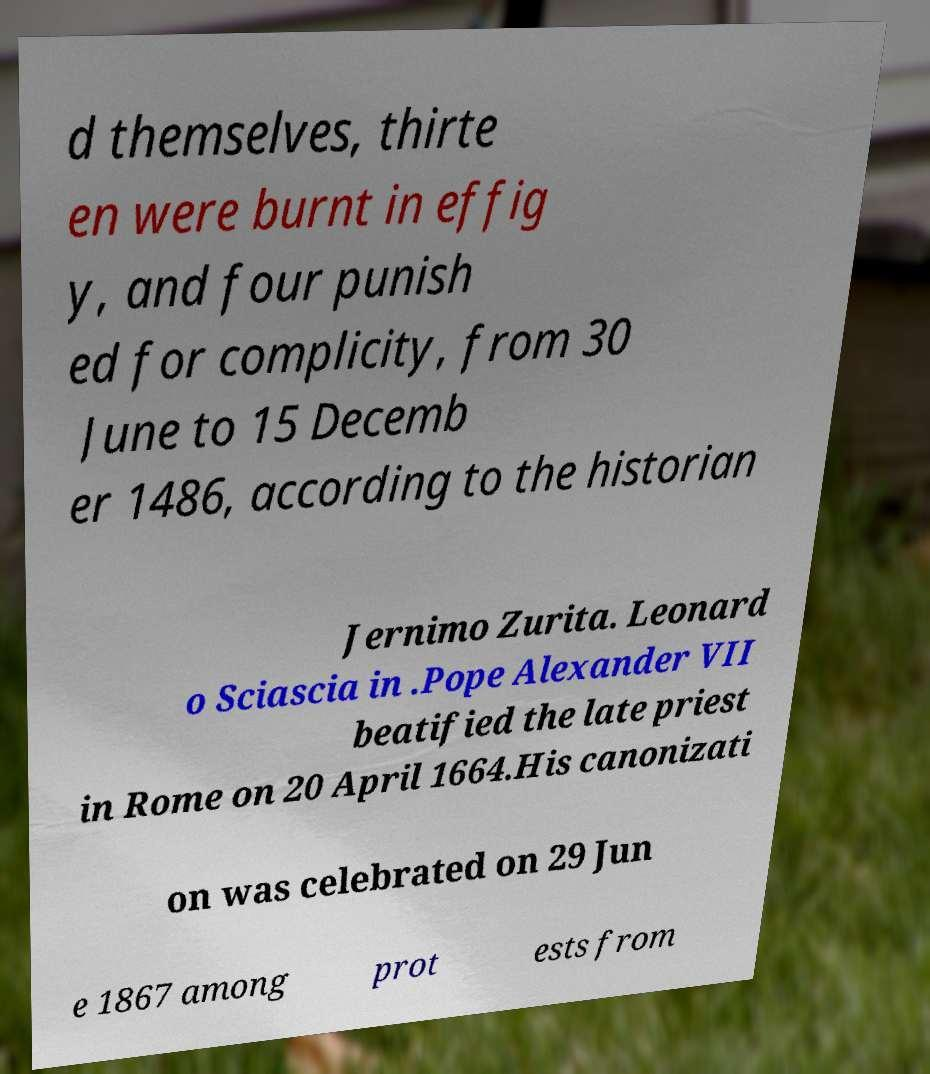Please identify and transcribe the text found in this image. d themselves, thirte en were burnt in effig y, and four punish ed for complicity, from 30 June to 15 Decemb er 1486, according to the historian Jernimo Zurita. Leonard o Sciascia in .Pope Alexander VII beatified the late priest in Rome on 20 April 1664.His canonizati on was celebrated on 29 Jun e 1867 among prot ests from 